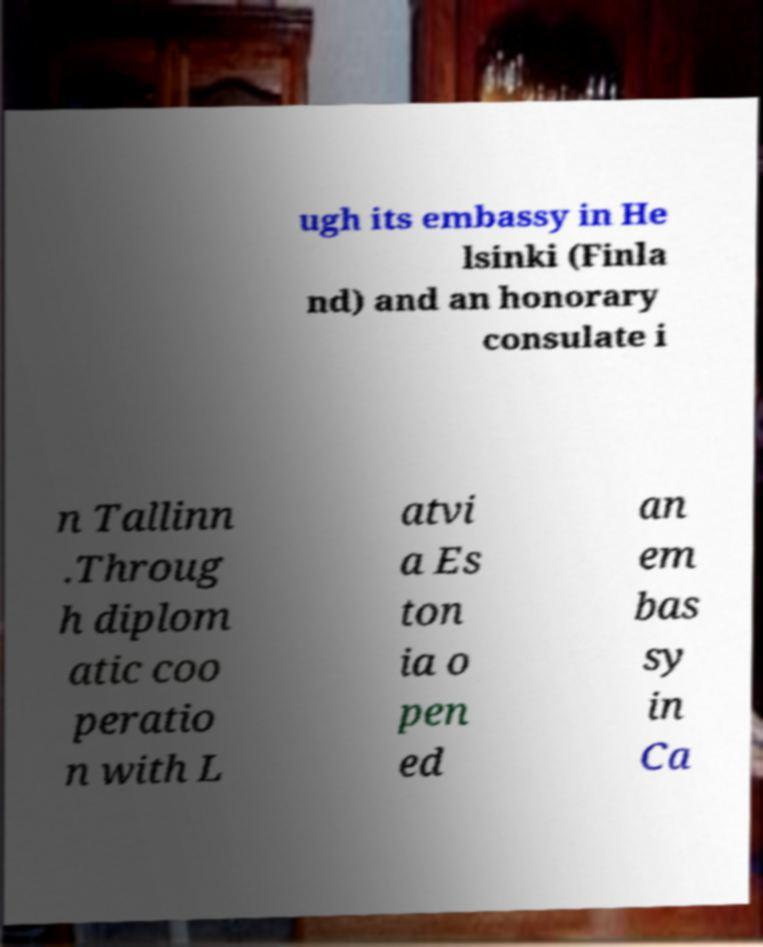I need the written content from this picture converted into text. Can you do that? ugh its embassy in He lsinki (Finla nd) and an honorary consulate i n Tallinn .Throug h diplom atic coo peratio n with L atvi a Es ton ia o pen ed an em bas sy in Ca 